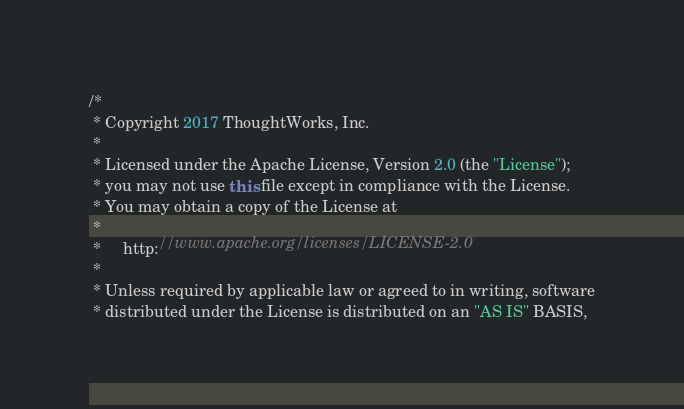<code> <loc_0><loc_0><loc_500><loc_500><_Java_>/*
 * Copyright 2017 ThoughtWorks, Inc.
 *
 * Licensed under the Apache License, Version 2.0 (the "License");
 * you may not use this file except in compliance with the License.
 * You may obtain a copy of the License at
 *
 *     http://www.apache.org/licenses/LICENSE-2.0
 *
 * Unless required by applicable law or agreed to in writing, software
 * distributed under the License is distributed on an "AS IS" BASIS,</code> 